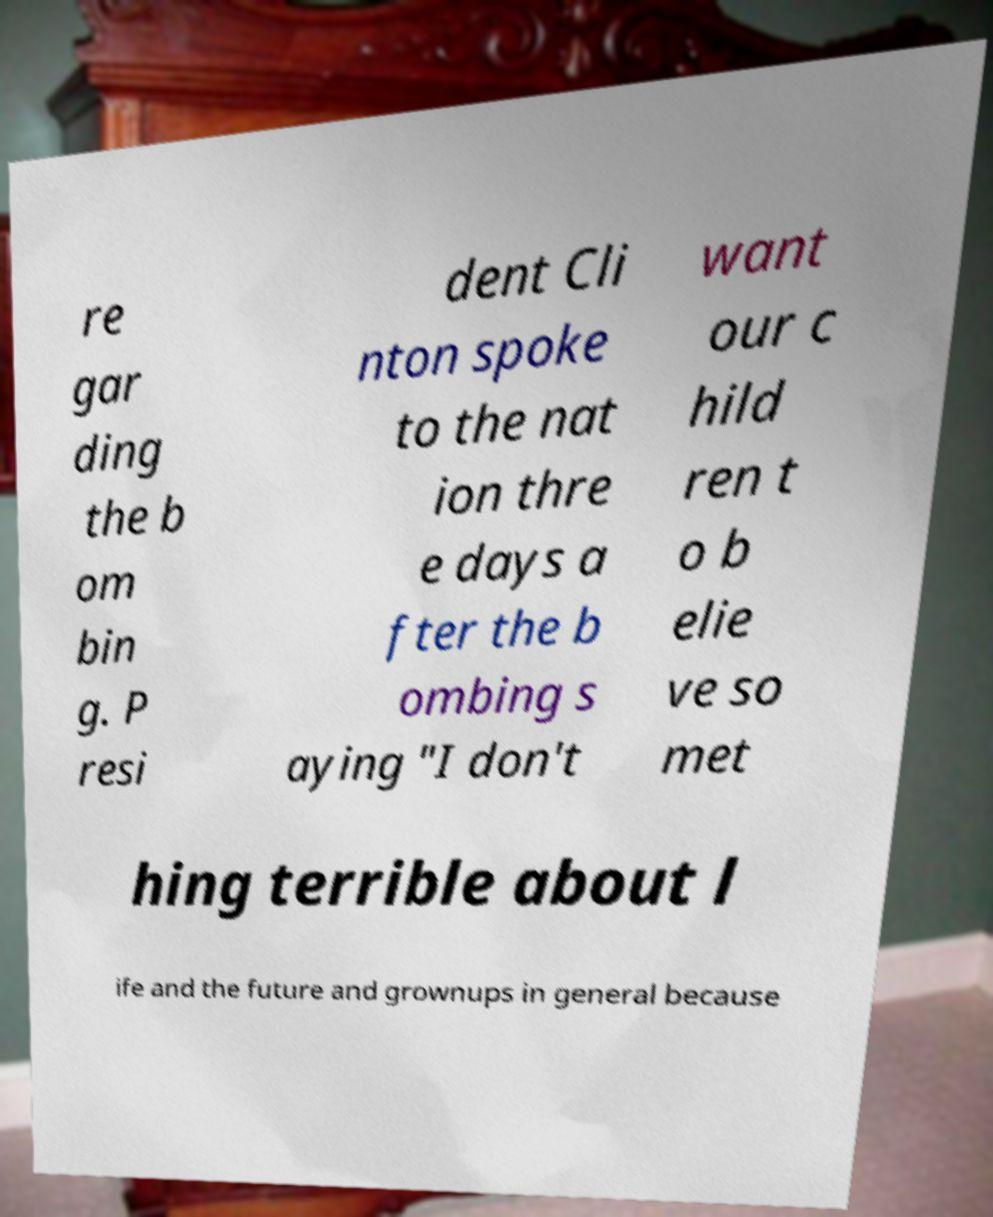Could you assist in decoding the text presented in this image and type it out clearly? re gar ding the b om bin g. P resi dent Cli nton spoke to the nat ion thre e days a fter the b ombing s aying "I don't want our c hild ren t o b elie ve so met hing terrible about l ife and the future and grownups in general because 